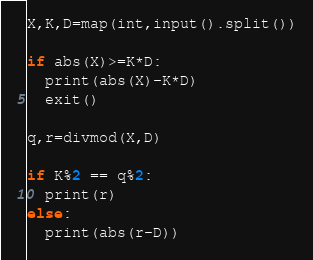<code> <loc_0><loc_0><loc_500><loc_500><_Python_>X,K,D=map(int,input().split())

if abs(X)>=K*D:
  print(abs(X)-K*D)
  exit()
  
q,r=divmod(X,D)

if K%2 == q%2:
  print(r)
else:
  print(abs(r-D))</code> 